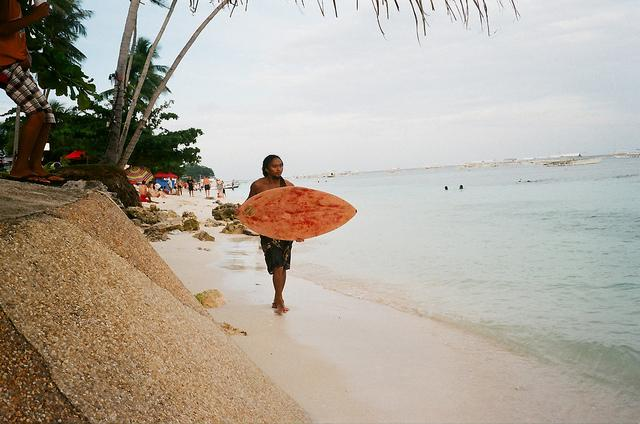Why is the man on the beach holding the object? to surf 